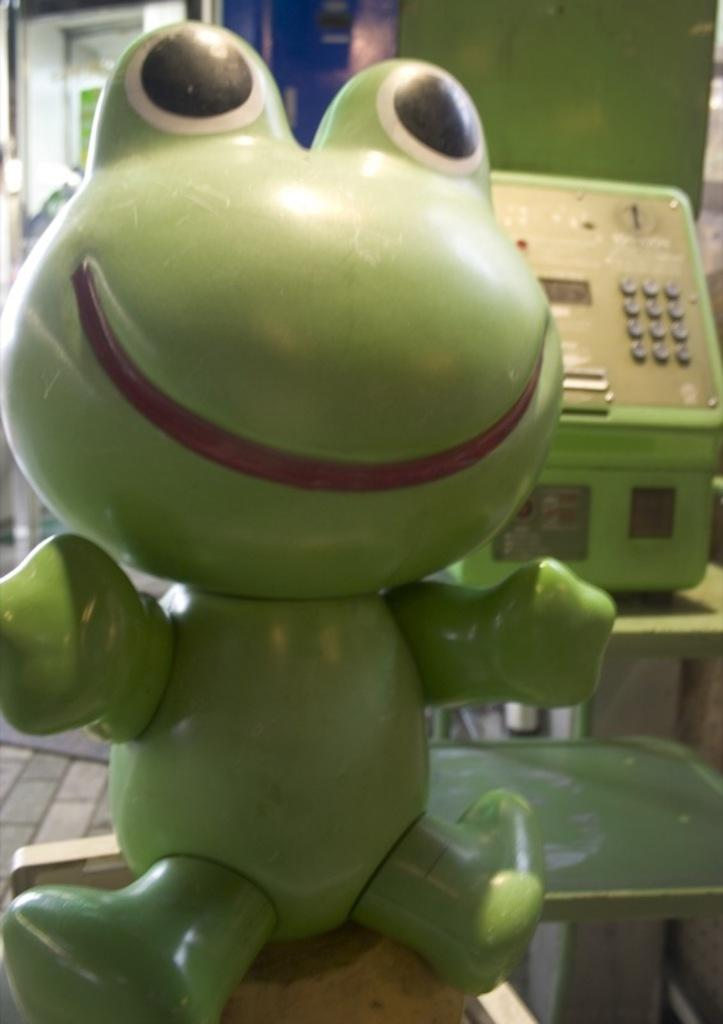What object can be seen in the image? There is a toy in the image. What can be seen in the background of the image? There is a machine in the background of the image. What type of brain is visible in the image? There is no brain visible in the image; it features a toy and a machine in the background. How many children are present in the image? There is no information about children in the image; it only mentions a toy and a machine. 